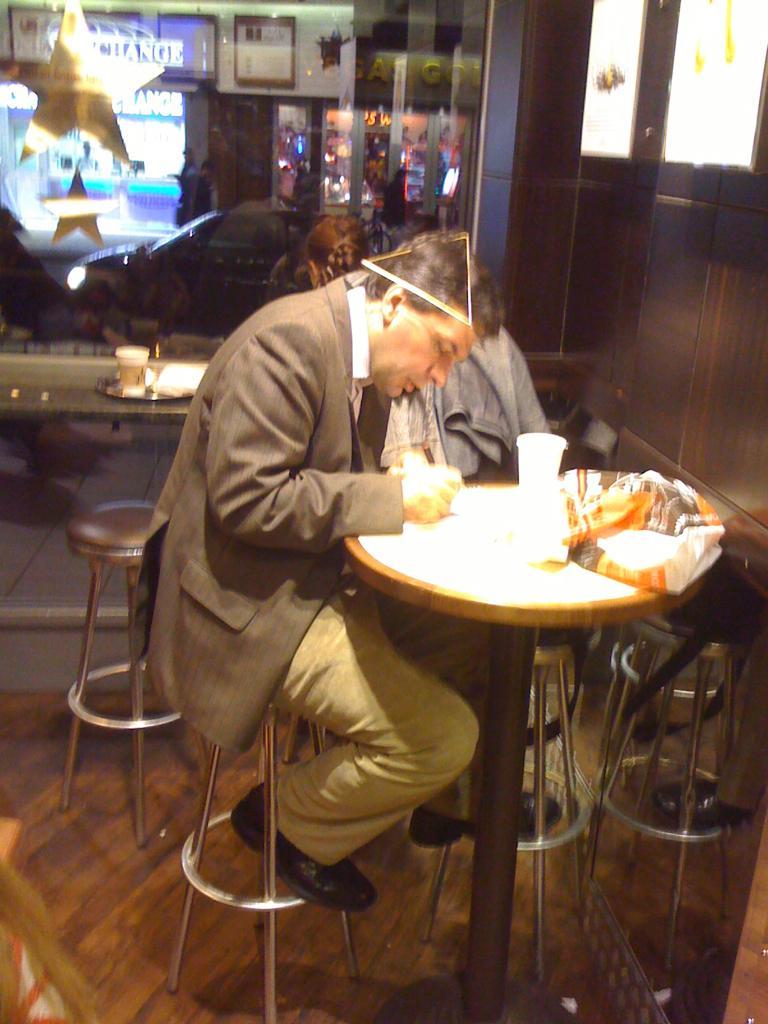Could you give a brief overview of what you see in this image? In the center of the image we can see a man sitting on a chair beside a table containing a glass and a cover on it. We can also see some chairs and clothes. On the backside we can see a table containing a glass and a plate. We can also see some stars, a building and a car on the road. 